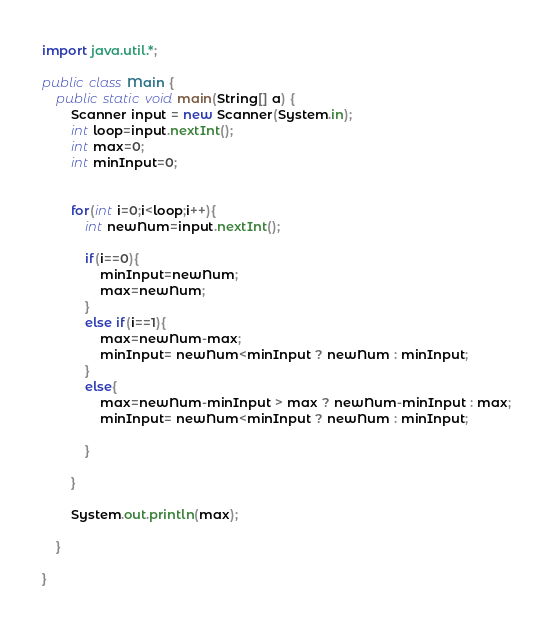<code> <loc_0><loc_0><loc_500><loc_500><_Java_>import java.util.*;

public class Main {
	public static void main(String[] a) {
		Scanner input = new Scanner(System.in);
		int loop=input.nextInt();
		int max=0;
		int minInput=0;
		
		
		for(int i=0;i<loop;i++){
			int newNum=input.nextInt();
			
			if(i==0){
				minInput=newNum;
				max=newNum;
			}
			else if(i==1){
				max=newNum-max;
				minInput= newNum<minInput ? newNum : minInput;
			}
			else{
				max=newNum-minInput > max ? newNum-minInput : max;
				minInput= newNum<minInput ? newNum : minInput;
				
			}
			
		}
		
		System.out.println(max);
		
	}

}</code> 